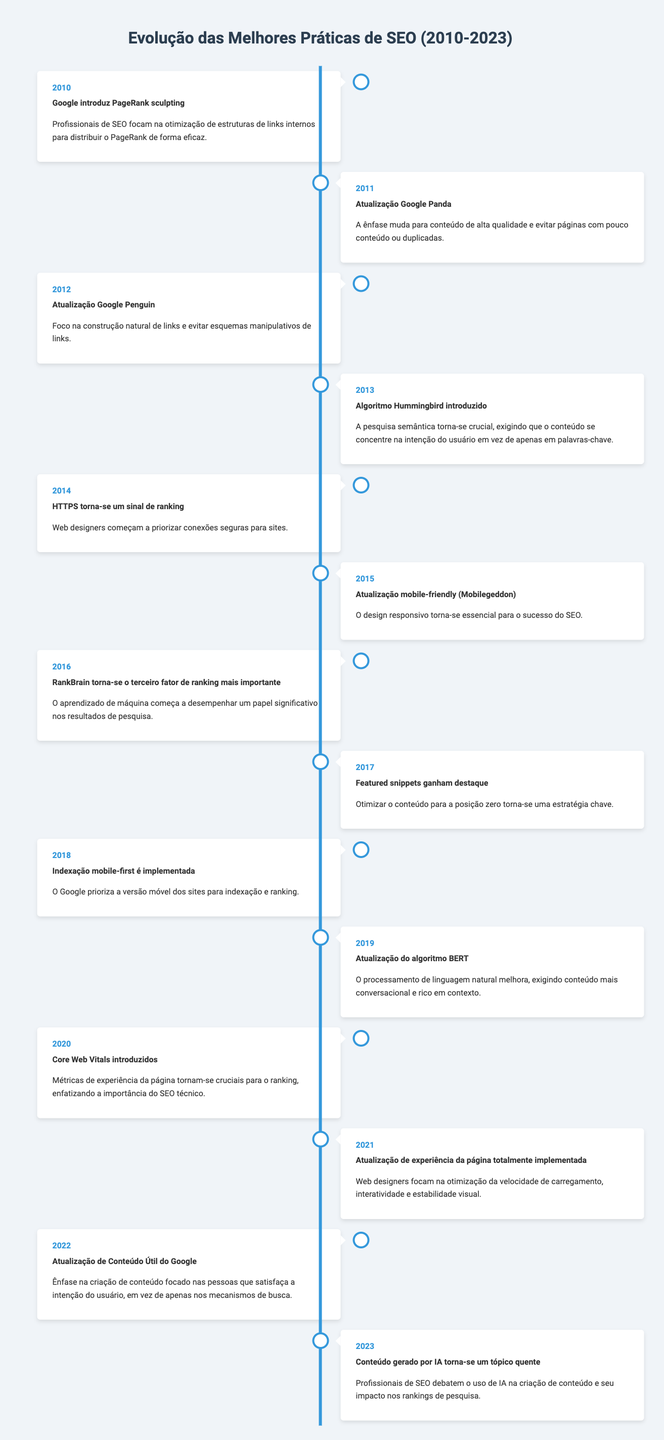What was the main focus of the Google Panda update in 2011? In 2011, the Google Panda update shifted the SEO focus to high-quality content, emphasizing the need to avoid thin or duplicate pages. This information can be found in the entry for the year 2011 in the timeline.
Answer: High-quality content and avoiding thin or duplicate pages In what year did HTTPS become a ranking signal? The timeline indicates that HTTPS became a ranking signal in 2014. This is clearly stated in the entry for that year.
Answer: 2014 Which update introduced semantic search and focused on user intent? The Hummingbird algorithm, introduced in 2013, made semantic search crucial, requiring content to focus on user intent rather than just keywords. This can be found in the timeline for 2013.
Answer: Hummingbird algorithm in 2013 How many key updates focused on mobile-friendliness from 2015 to 2022? From 2015 onwards, the timeline shows two key updates related to mobile-friendliness: the mobile-friendly update (Mobilegeddon) in 2015 and the mobile-first indexing rollout in 2018. We count these two events in the specified range.
Answer: Two updates Was there an update related to natural language processing in 2019? Yes, the BERT algorithm update introduced in 2019 improved natural language processing, requiring more conversational and context-rich content. This is clearly stated in the timeline for that year.
Answer: Yes What significant shift in SEO occurred after the introduction of the Core Web Vitals in 2020? After introducing Core Web Vitals in 2020, which emphasized the importance of technical SEO, the next major event is the full rollout of the Page Experience update in 2021, where web designers focused on optimizing loading speed, interactivity, and visual stability. This indicates a continuing trend towards enhancing user experience.
Answer: Continued emphasis on technical SEO and user experience What is the key theme of Google's Helpful Content Update in 2022? The Helpful Content Update in 2022 emphasized creating people-first content, focusing on satisfying user intent rather than solely pleasing search engines. This is detailed in the timeline for 2022.
Answer: Creating people-first content that satisfies user intent Which update in 2023 sparked debates among SEO practitioners regarding AI? In 2023, the introduction of AI-generated content as a hot topic led to debates among SEO practitioners about its creation and impact on search rankings, as noted in the timeline for that year.
Answer: AI-generated content discussion in 2023 